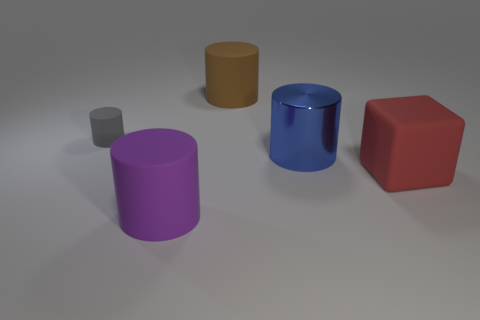Add 4 purple cylinders. How many objects exist? 9 Subtract all cubes. How many objects are left? 4 Add 3 metallic spheres. How many metallic spheres exist? 3 Subtract 0 gray spheres. How many objects are left? 5 Subtract all gray objects. Subtract all purple metal cylinders. How many objects are left? 4 Add 1 gray things. How many gray things are left? 2 